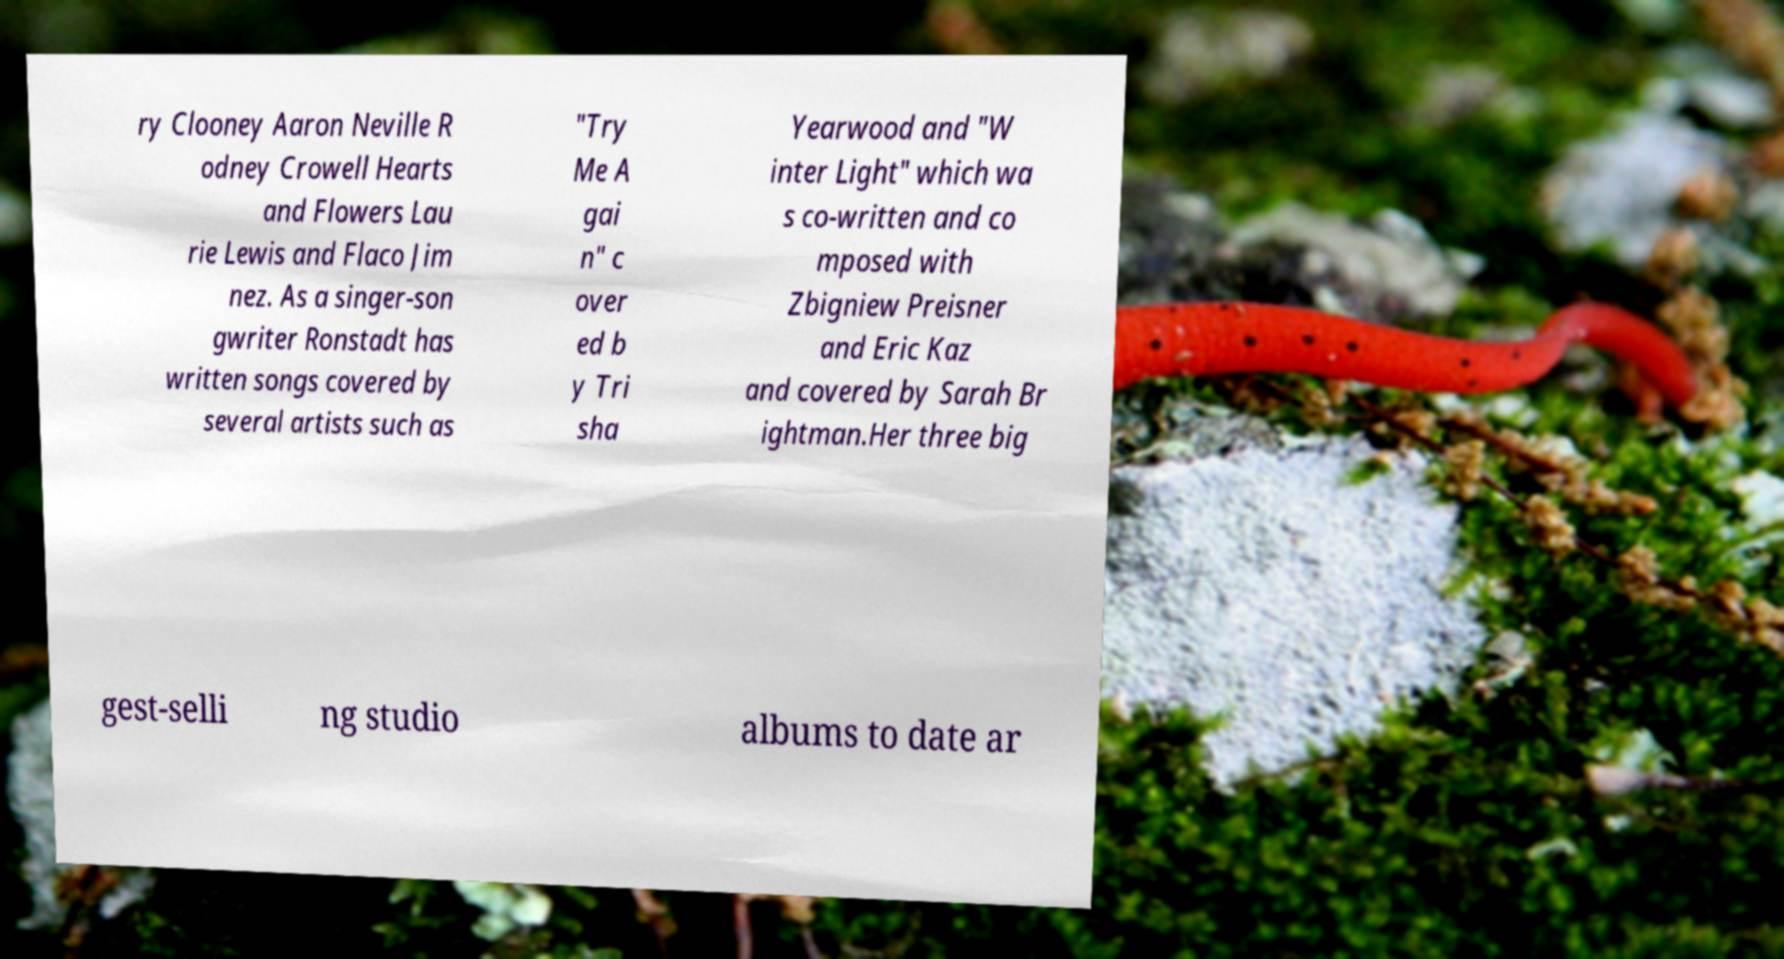There's text embedded in this image that I need extracted. Can you transcribe it verbatim? ry Clooney Aaron Neville R odney Crowell Hearts and Flowers Lau rie Lewis and Flaco Jim nez. As a singer-son gwriter Ronstadt has written songs covered by several artists such as "Try Me A gai n" c over ed b y Tri sha Yearwood and "W inter Light" which wa s co-written and co mposed with Zbigniew Preisner and Eric Kaz and covered by Sarah Br ightman.Her three big gest-selli ng studio albums to date ar 